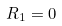<formula> <loc_0><loc_0><loc_500><loc_500>R _ { 1 } = 0</formula> 